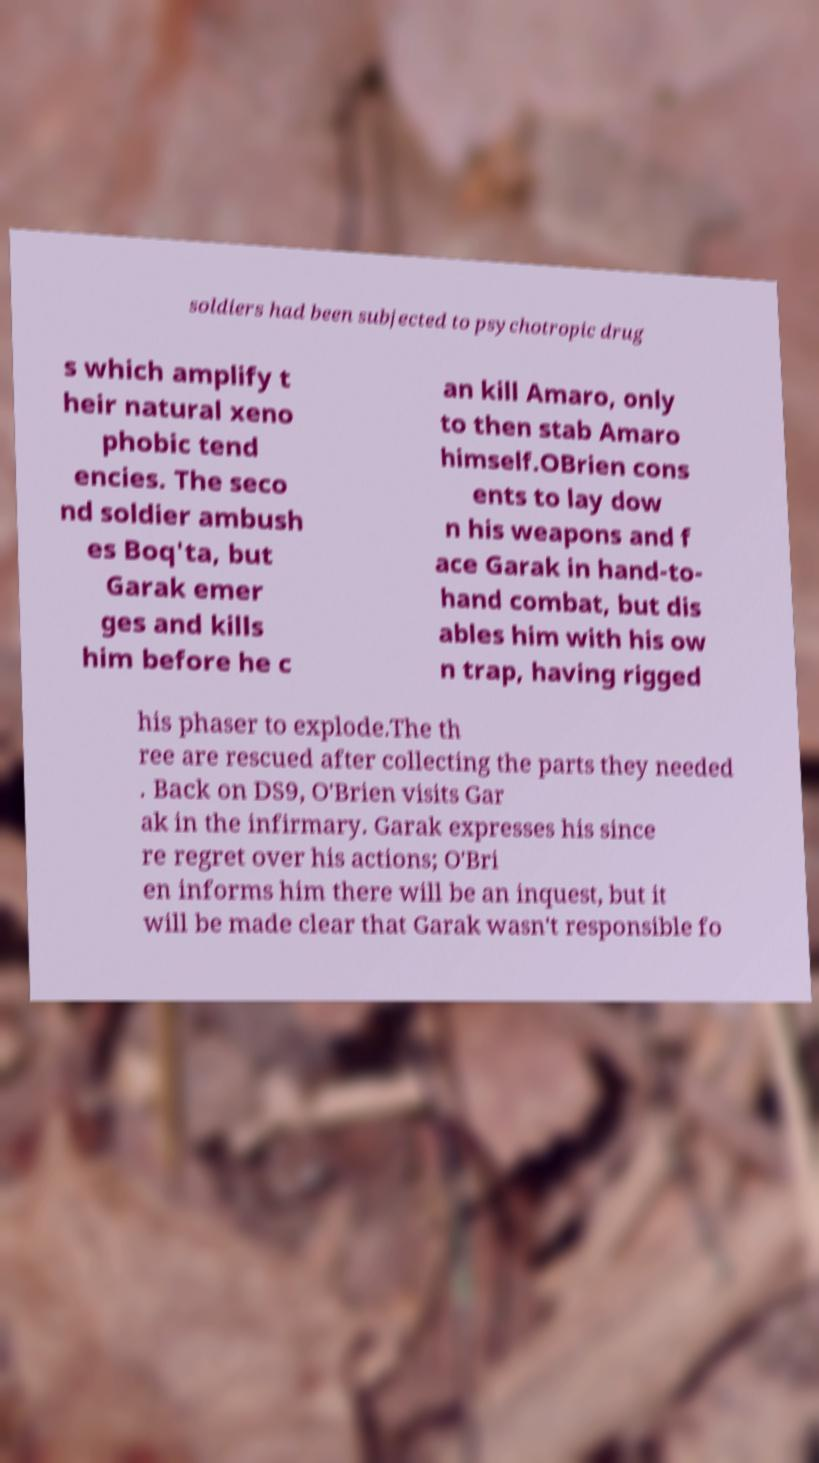For documentation purposes, I need the text within this image transcribed. Could you provide that? soldiers had been subjected to psychotropic drug s which amplify t heir natural xeno phobic tend encies. The seco nd soldier ambush es Boq'ta, but Garak emer ges and kills him before he c an kill Amaro, only to then stab Amaro himself.OBrien cons ents to lay dow n his weapons and f ace Garak in hand-to- hand combat, but dis ables him with his ow n trap, having rigged his phaser to explode.The th ree are rescued after collecting the parts they needed . Back on DS9, O'Brien visits Gar ak in the infirmary. Garak expresses his since re regret over his actions; O'Bri en informs him there will be an inquest, but it will be made clear that Garak wasn't responsible fo 